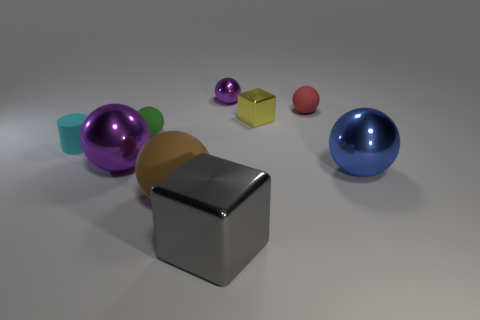Is there anything else that is made of the same material as the small green sphere?
Ensure brevity in your answer.  Yes. Is the material of the gray cube the same as the purple object in front of the yellow metallic cube?
Your response must be concise. Yes. The big metal object that is in front of the big metal object that is on the right side of the tiny purple ball is what shape?
Ensure brevity in your answer.  Cube. How many big things are purple spheres or blue metallic balls?
Provide a succinct answer. 2. How many yellow metal objects have the same shape as the gray shiny object?
Give a very brief answer. 1. Is the shape of the green object the same as the tiny thing behind the small red matte sphere?
Offer a terse response. Yes. What number of green rubber balls are on the left side of the green thing?
Provide a short and direct response. 0. Is there a blue metallic sphere of the same size as the cyan cylinder?
Offer a terse response. No. There is a large object on the right side of the red rubber ball; is it the same shape as the tiny green object?
Your response must be concise. Yes. What color is the tiny cylinder?
Ensure brevity in your answer.  Cyan. 